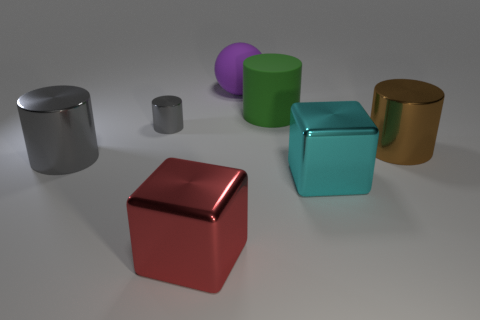What color is the big metallic thing that is right of the big red metallic object and behind the big cyan block?
Your answer should be compact. Brown. Does the red object have the same size as the metallic cube that is behind the large red block?
Your answer should be very brief. Yes. There is a thing in front of the large cyan metal block; what is its shape?
Ensure brevity in your answer.  Cube. Is there any other thing that has the same material as the red block?
Give a very brief answer. Yes. Is the number of gray cylinders on the left side of the purple rubber object greater than the number of tiny gray metal cylinders?
Provide a short and direct response. Yes. There is a big metallic cylinder left of the gray cylinder that is to the right of the big gray cylinder; how many cylinders are behind it?
Offer a very short reply. 3. There is a rubber thing that is behind the large green matte thing; is its size the same as the gray cylinder that is behind the large brown metallic thing?
Your answer should be very brief. No. What material is the gray cylinder that is to the left of the gray metallic cylinder to the right of the big gray thing made of?
Your response must be concise. Metal. What number of objects are red cubes in front of the brown metal thing or gray objects?
Provide a short and direct response. 3. Are there the same number of large blocks right of the red shiny block and gray metal things left of the large gray cylinder?
Keep it short and to the point. No. 